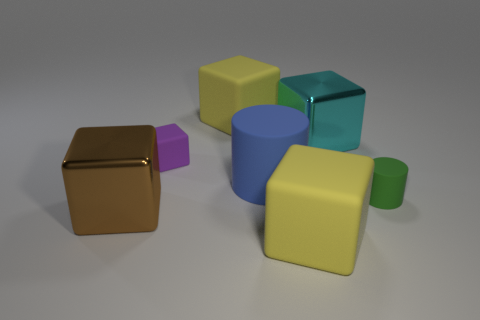Is the number of large brown blocks right of the big brown metal block less than the number of rubber cylinders that are in front of the big blue cylinder?
Make the answer very short. Yes. What is the color of the tiny cylinder?
Your answer should be compact. Green. There is a big yellow rubber thing that is to the right of the large rubber cylinder behind the rubber object on the right side of the cyan shiny thing; what shape is it?
Offer a terse response. Cube. There is a big yellow object that is in front of the cyan cube; what material is it?
Your answer should be compact. Rubber. What size is the blue object that is in front of the big yellow block that is behind the metal object that is behind the purple cube?
Give a very brief answer. Large. Do the blue rubber object and the shiny cube to the right of the big matte cylinder have the same size?
Ensure brevity in your answer.  Yes. There is a metallic thing that is in front of the blue cylinder; what color is it?
Ensure brevity in your answer.  Brown. The big yellow rubber thing in front of the tiny green cylinder has what shape?
Provide a short and direct response. Cube. How many green things are tiny matte things or tiny cylinders?
Offer a very short reply. 1. Is the big cyan block made of the same material as the green thing?
Give a very brief answer. No. 